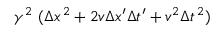<formula> <loc_0><loc_0><loc_500><loc_500>\gamma ^ { 2 } \ ( \Delta x ^ { \, 2 } + 2 v \Delta x ^ { \prime } \Delta t ^ { \prime } + v ^ { 2 } \Delta t ^ { \, 2 } )</formula> 